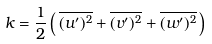<formula> <loc_0><loc_0><loc_500><loc_500>k = { \frac { 1 } { 2 } } \left ( \, { \overline { { ( u ^ { \prime } ) ^ { 2 } } } } + { \overline { { ( v ^ { \prime } ) ^ { 2 } } } } + { \overline { { ( w ^ { \prime } ) ^ { 2 } } } } \, \right )</formula> 